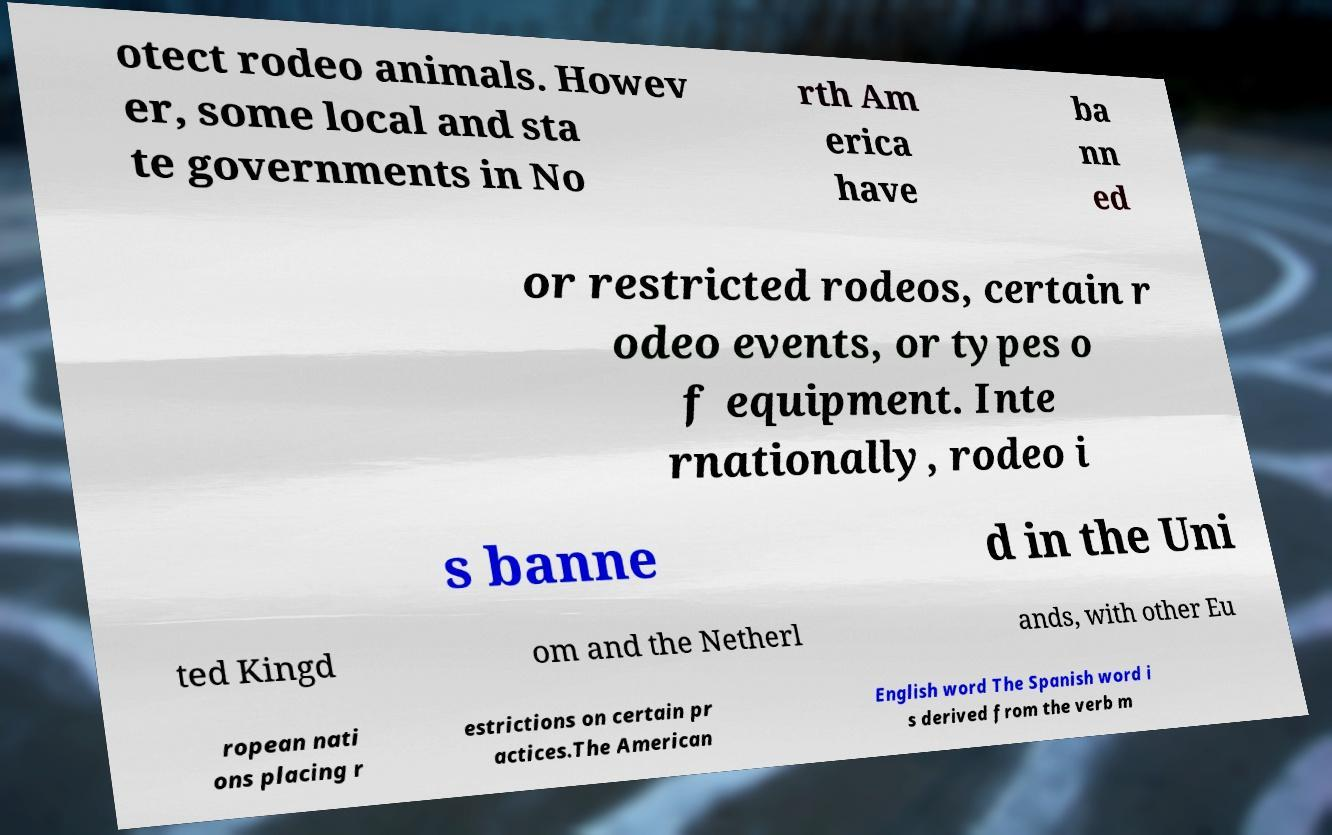I need the written content from this picture converted into text. Can you do that? otect rodeo animals. Howev er, some local and sta te governments in No rth Am erica have ba nn ed or restricted rodeos, certain r odeo events, or types o f equipment. Inte rnationally, rodeo i s banne d in the Uni ted Kingd om and the Netherl ands, with other Eu ropean nati ons placing r estrictions on certain pr actices.The American English word The Spanish word i s derived from the verb m 